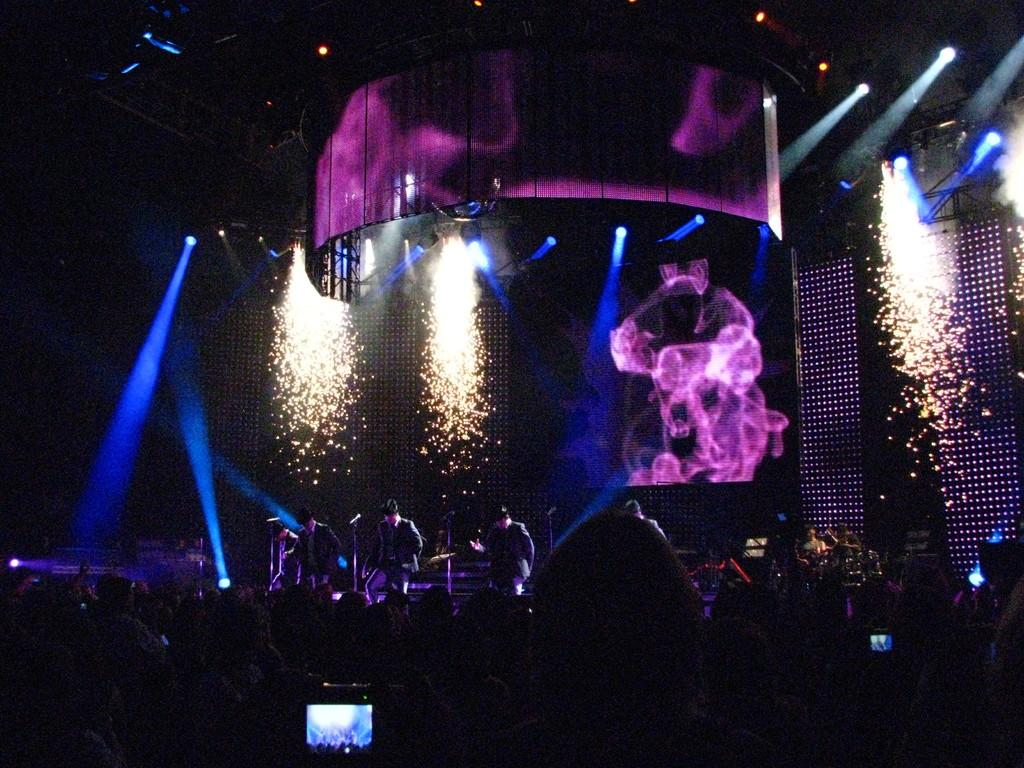What is happening on the stage in the image? There are people standing on the stage in the image. What objects are present that might be used for amplifying sound? There are microphones in the image. What structures can be seen in the image? There are stands in the image. How many people are visible in the image? There is a group of people in the image. What type of lighting is present in the image? Colorful lights are visible in the image. What is the color of the background in the image? The background of the image is dark. What type of protest is happening in the image? There is no protest visible in the image; it features people standing on a stage with microphones and stands. What type of machine is being used by the mom in the image? There is no mom or machine present in the image. 